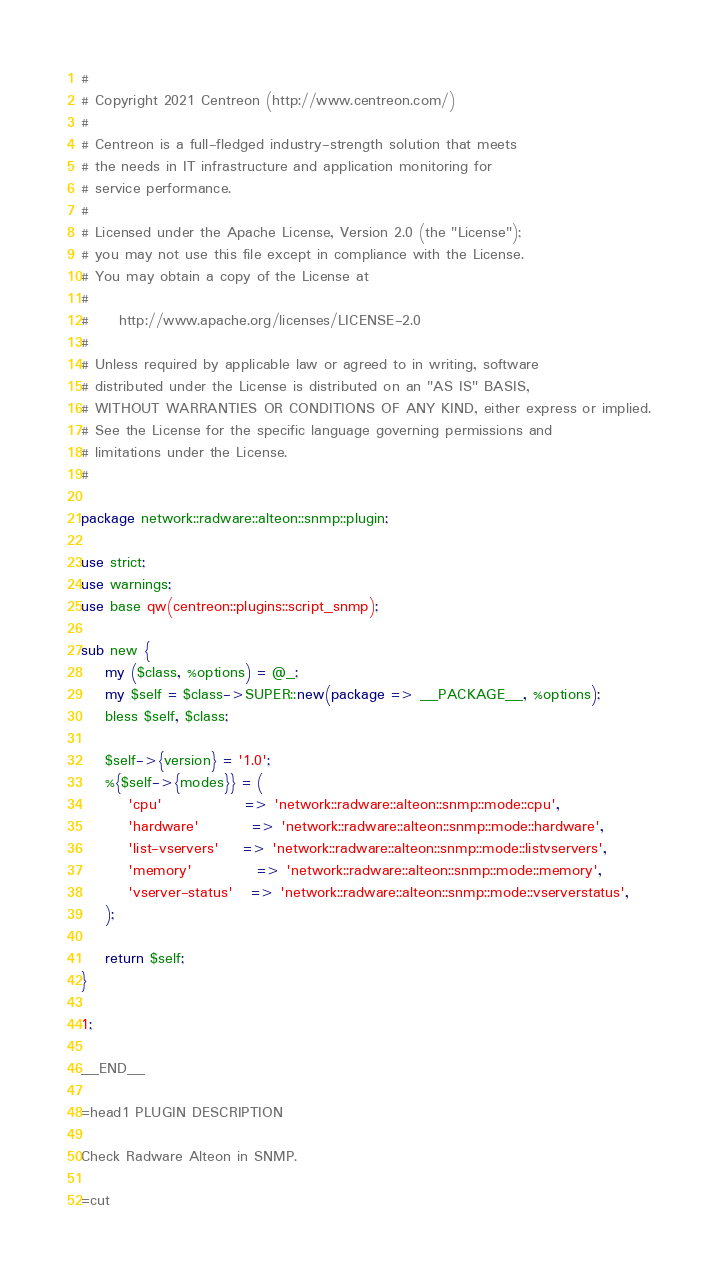<code> <loc_0><loc_0><loc_500><loc_500><_Perl_>#
# Copyright 2021 Centreon (http://www.centreon.com/)
#
# Centreon is a full-fledged industry-strength solution that meets
# the needs in IT infrastructure and application monitoring for
# service performance.
#
# Licensed under the Apache License, Version 2.0 (the "License");
# you may not use this file except in compliance with the License.
# You may obtain a copy of the License at
#
#     http://www.apache.org/licenses/LICENSE-2.0
#
# Unless required by applicable law or agreed to in writing, software
# distributed under the License is distributed on an "AS IS" BASIS,
# WITHOUT WARRANTIES OR CONDITIONS OF ANY KIND, either express or implied.
# See the License for the specific language governing permissions and
# limitations under the License.
#

package network::radware::alteon::snmp::plugin;

use strict;
use warnings;
use base qw(centreon::plugins::script_snmp);

sub new {
    my ($class, %options) = @_;
    my $self = $class->SUPER::new(package => __PACKAGE__, %options);
    bless $self, $class;

    $self->{version} = '1.0';
    %{$self->{modes}} = (
        'cpu'              => 'network::radware::alteon::snmp::mode::cpu',
        'hardware'         => 'network::radware::alteon::snmp::mode::hardware',
        'list-vservers'    => 'network::radware::alteon::snmp::mode::listvservers',
        'memory'           => 'network::radware::alteon::snmp::mode::memory',
        'vserver-status'   => 'network::radware::alteon::snmp::mode::vserverstatus',
    );

    return $self;
}

1;

__END__

=head1 PLUGIN DESCRIPTION

Check Radware Alteon in SNMP.

=cut
</code> 